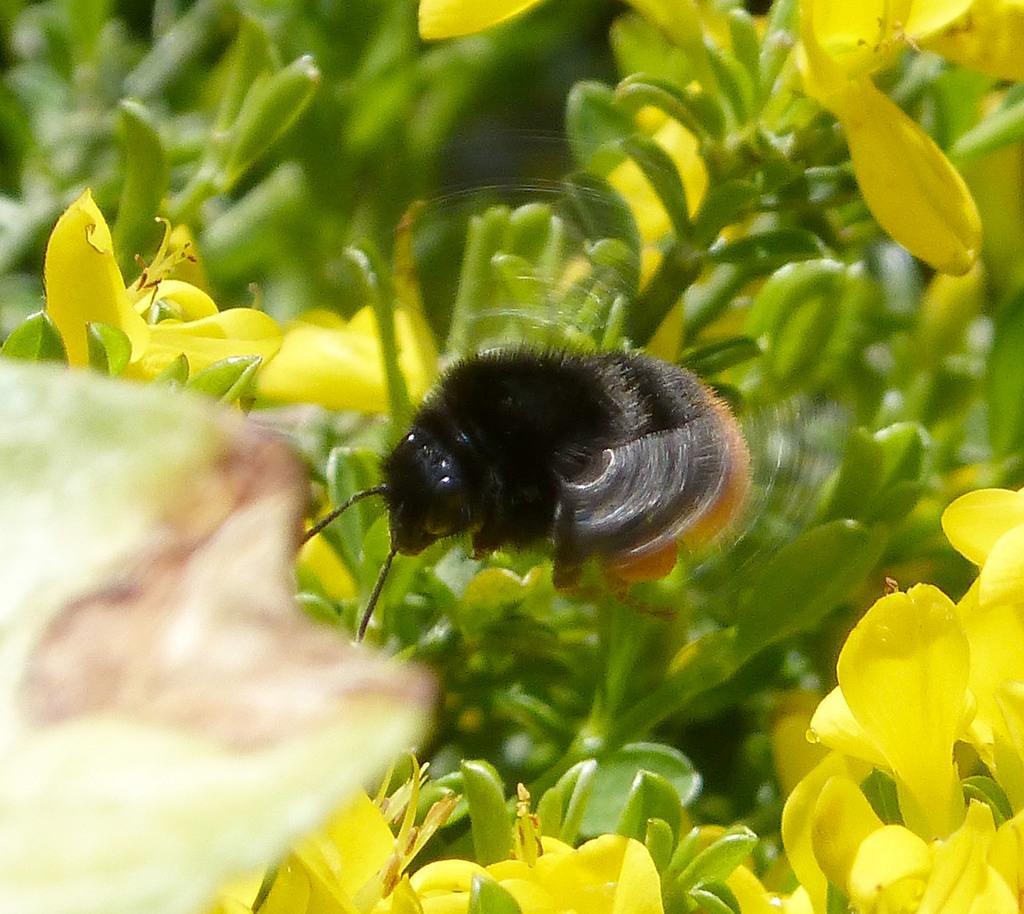How would you summarize this image in a sentence or two? In the picture we can see some plants with flowers which are yellow in color and near it, we can see a bug which is black in color with some part brown in color. 